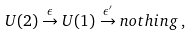<formula> <loc_0><loc_0><loc_500><loc_500>U ( 2 ) \stackrel { \epsilon } { \rightarrow } U ( 1 ) \stackrel { \epsilon ^ { \prime } } { \rightarrow } n o t h i n g \, ,</formula> 